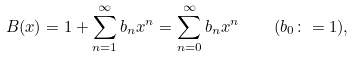<formula> <loc_0><loc_0><loc_500><loc_500>B ( x ) = 1 + \sum _ { n = 1 } ^ { \infty } b _ { n } x ^ { n } = \sum _ { n = 0 } ^ { \infty } b _ { n } x ^ { n } \quad ( b _ { 0 } \colon = 1 ) ,</formula> 